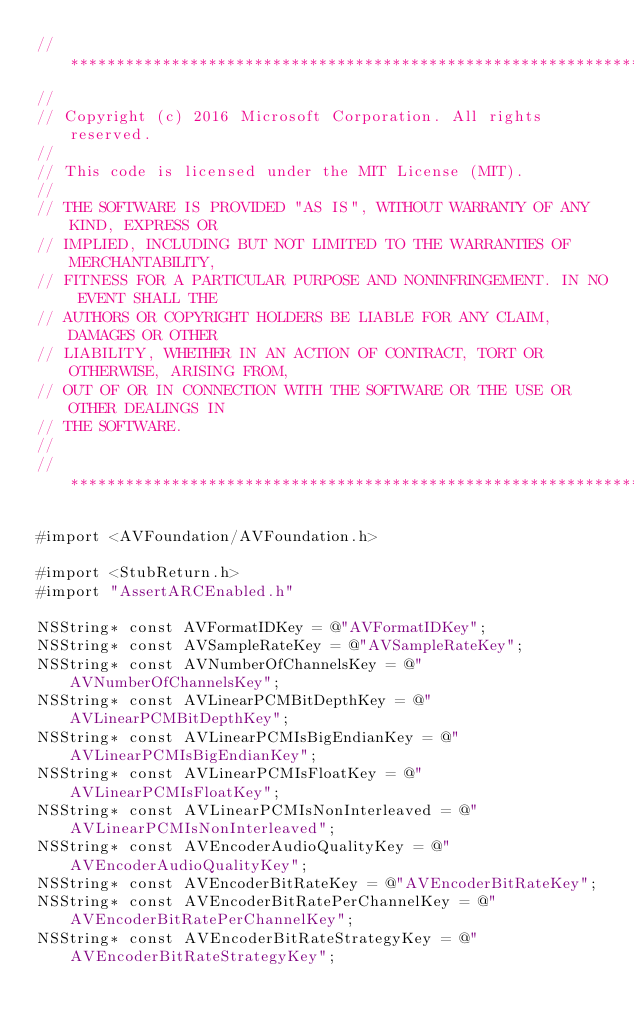<code> <loc_0><loc_0><loc_500><loc_500><_ObjectiveC_>//******************************************************************************
//
// Copyright (c) 2016 Microsoft Corporation. All rights reserved.
//
// This code is licensed under the MIT License (MIT).
//
// THE SOFTWARE IS PROVIDED "AS IS", WITHOUT WARRANTY OF ANY KIND, EXPRESS OR
// IMPLIED, INCLUDING BUT NOT LIMITED TO THE WARRANTIES OF MERCHANTABILITY,
// FITNESS FOR A PARTICULAR PURPOSE AND NONINFRINGEMENT. IN NO EVENT SHALL THE
// AUTHORS OR COPYRIGHT HOLDERS BE LIABLE FOR ANY CLAIM, DAMAGES OR OTHER
// LIABILITY, WHETHER IN AN ACTION OF CONTRACT, TORT OR OTHERWISE, ARISING FROM,
// OUT OF OR IN CONNECTION WITH THE SOFTWARE OR THE USE OR OTHER DEALINGS IN
// THE SOFTWARE.
//
//******************************************************************************

#import <AVFoundation/AVFoundation.h>

#import <StubReturn.h>
#import "AssertARCEnabled.h"

NSString* const AVFormatIDKey = @"AVFormatIDKey";
NSString* const AVSampleRateKey = @"AVSampleRateKey";
NSString* const AVNumberOfChannelsKey = @"AVNumberOfChannelsKey";
NSString* const AVLinearPCMBitDepthKey = @"AVLinearPCMBitDepthKey";
NSString* const AVLinearPCMIsBigEndianKey = @"AVLinearPCMIsBigEndianKey";
NSString* const AVLinearPCMIsFloatKey = @"AVLinearPCMIsFloatKey";
NSString* const AVLinearPCMIsNonInterleaved = @"AVLinearPCMIsNonInterleaved";
NSString* const AVEncoderAudioQualityKey = @"AVEncoderAudioQualityKey";
NSString* const AVEncoderBitRateKey = @"AVEncoderBitRateKey";
NSString* const AVEncoderBitRatePerChannelKey = @"AVEncoderBitRatePerChannelKey";
NSString* const AVEncoderBitRateStrategyKey = @"AVEncoderBitRateStrategyKey";</code> 